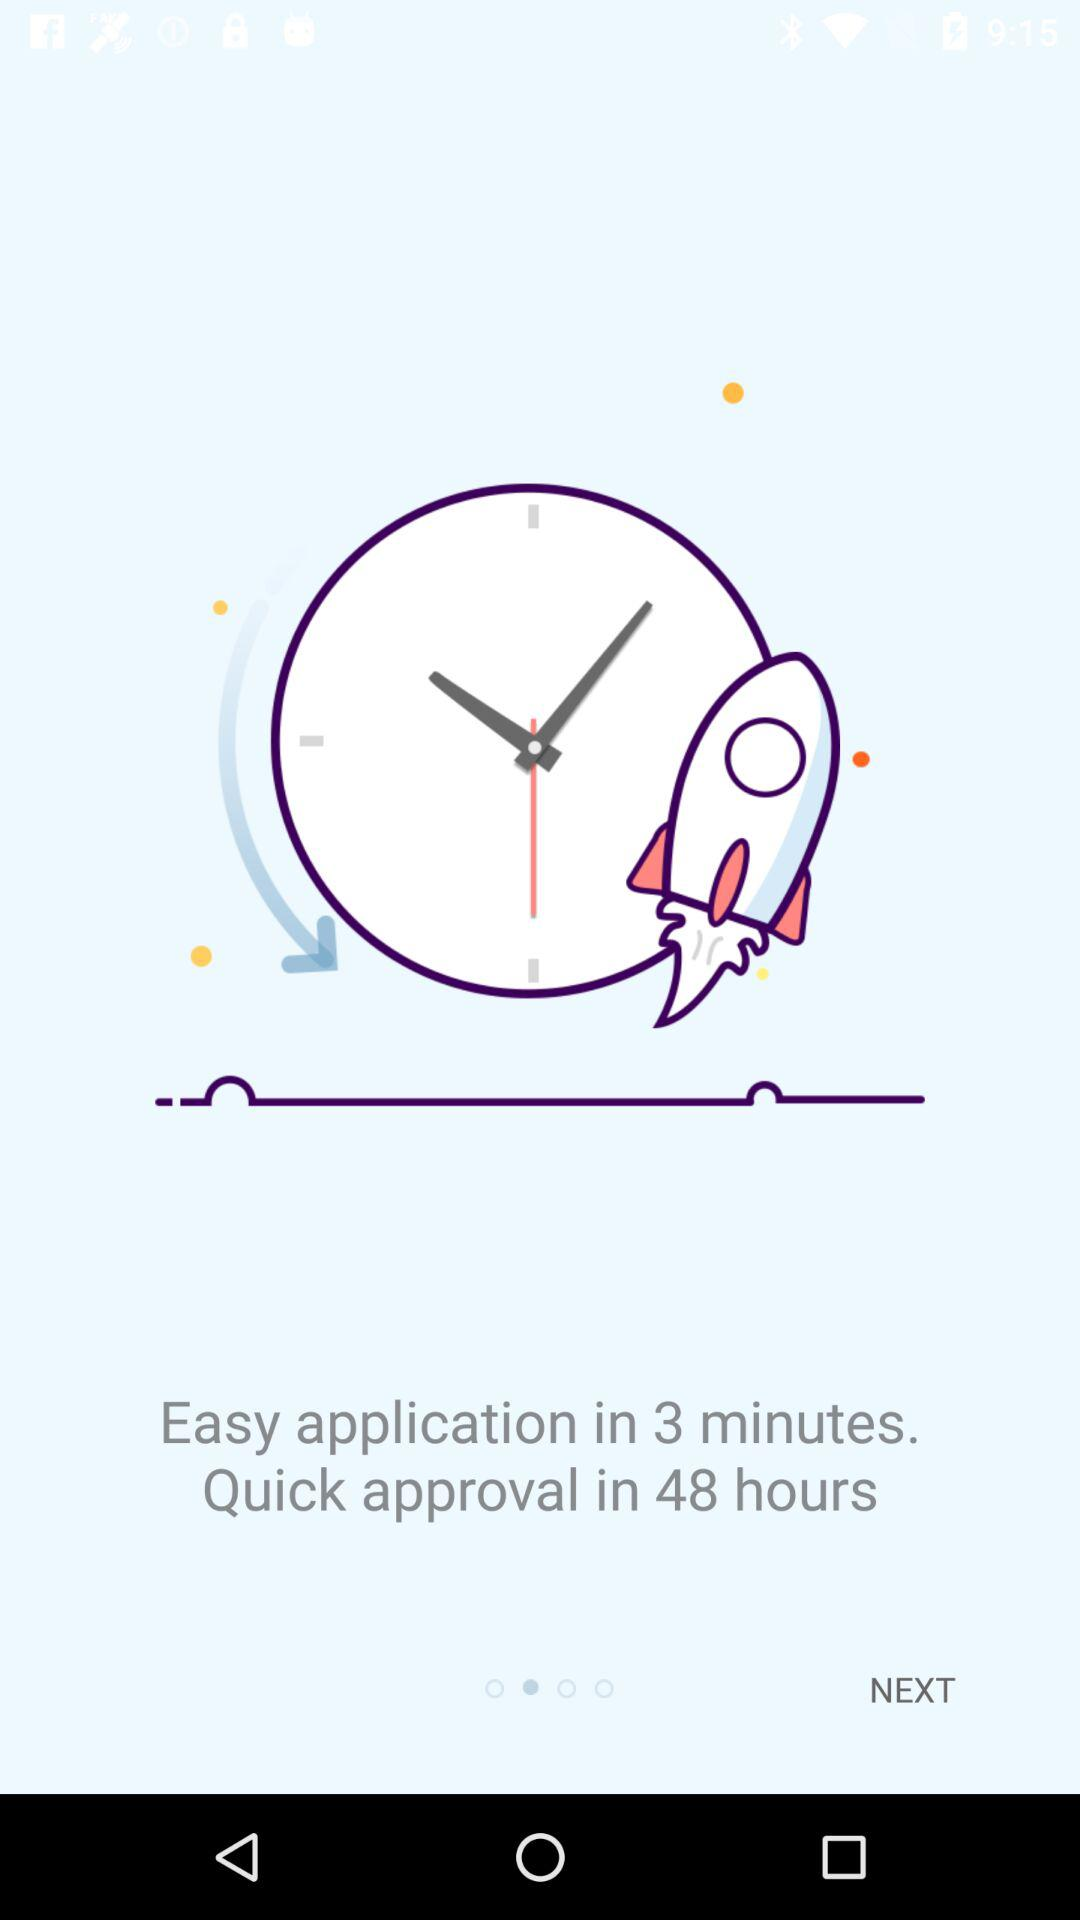What is the time duration of the easy application? The time duration of the easy application is 3 minutes. 